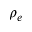Convert formula to latex. <formula><loc_0><loc_0><loc_500><loc_500>\rho _ { e }</formula> 